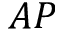Convert formula to latex. <formula><loc_0><loc_0><loc_500><loc_500>A P</formula> 